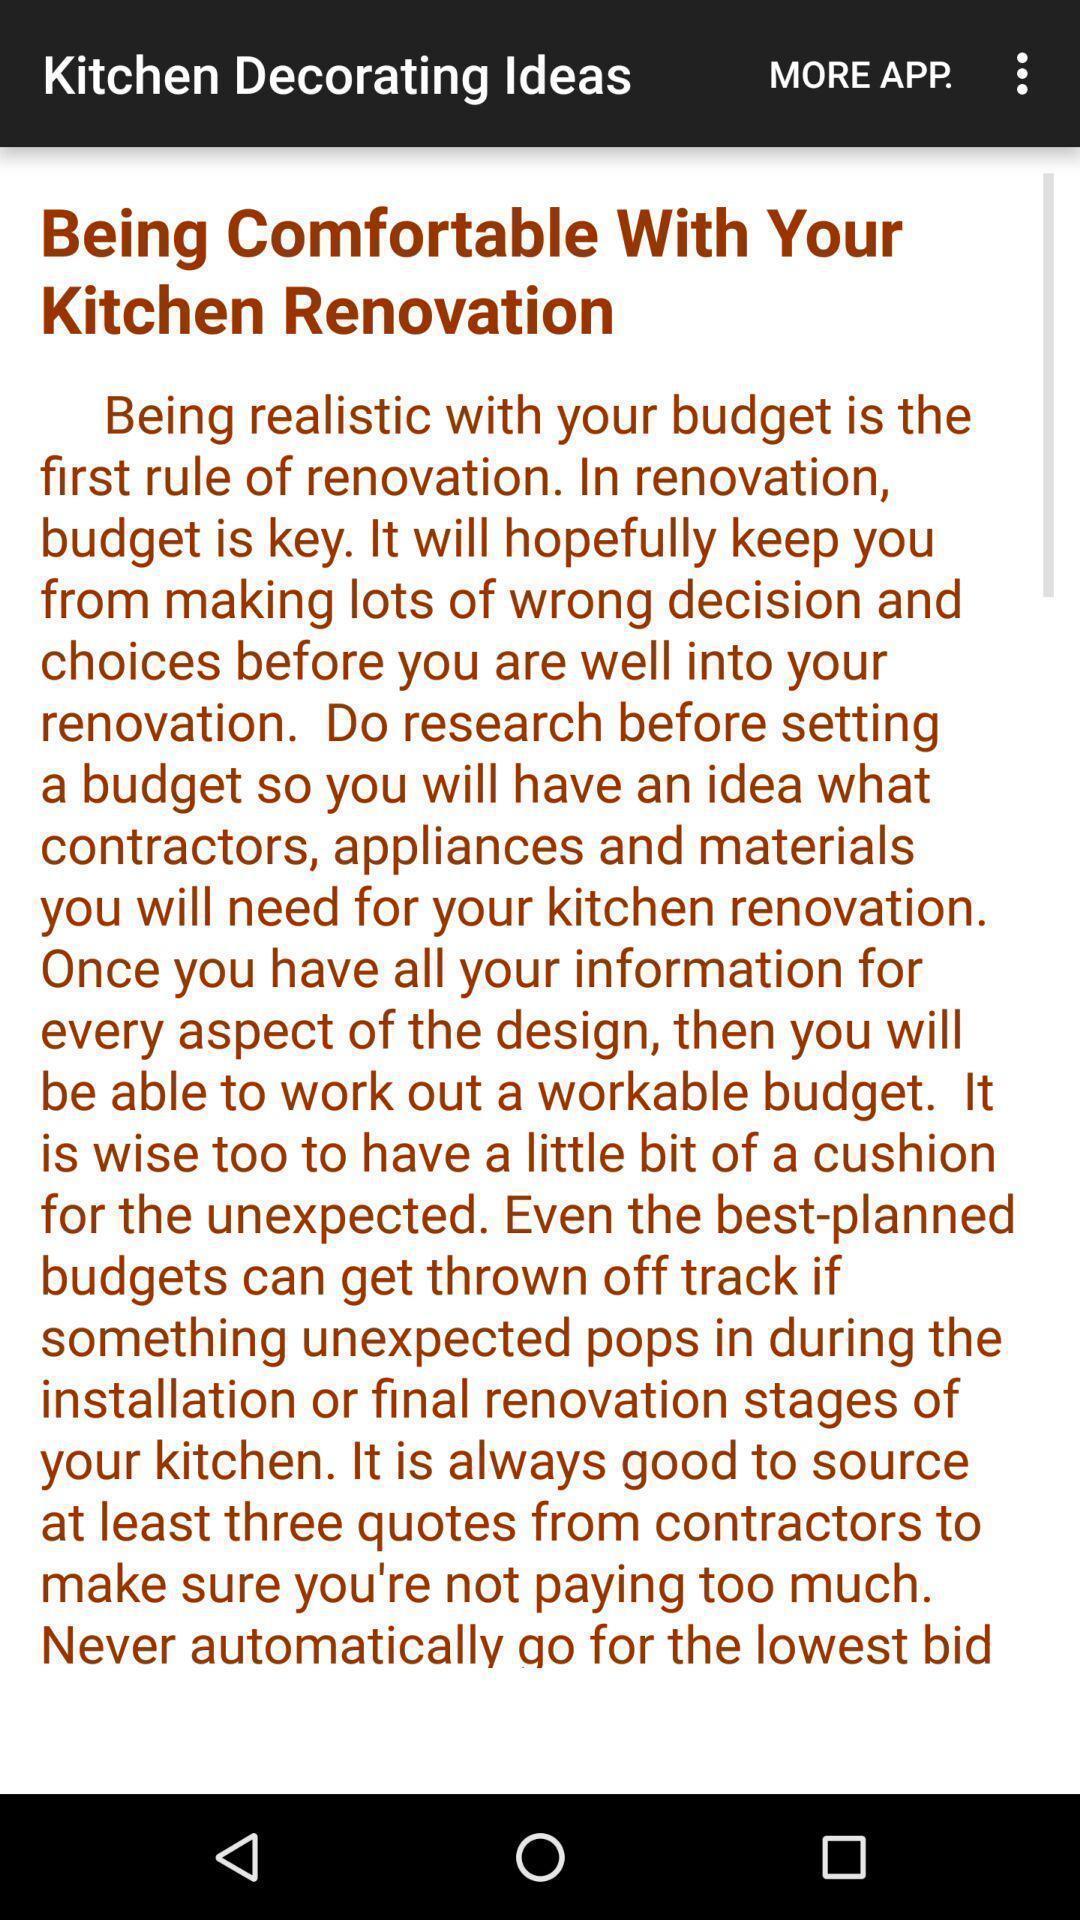What details can you identify in this image? Screen displaying kitchen decorating ideas. 